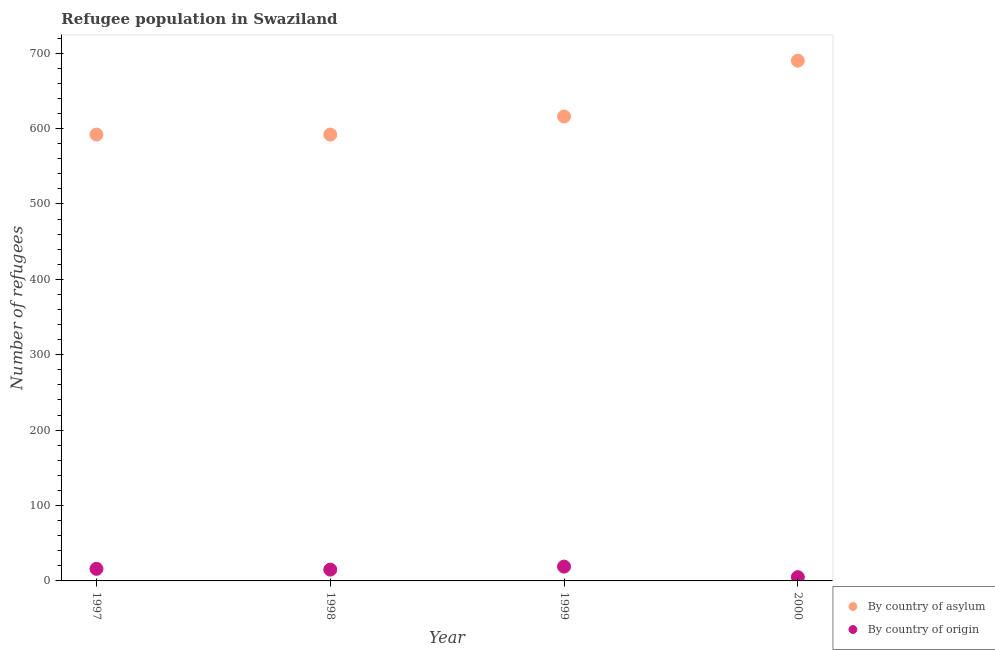How many different coloured dotlines are there?
Your answer should be compact. 2. Is the number of dotlines equal to the number of legend labels?
Offer a terse response. Yes. What is the number of refugees by country of asylum in 1997?
Offer a terse response. 592. Across all years, what is the maximum number of refugees by country of asylum?
Your response must be concise. 690. Across all years, what is the minimum number of refugees by country of origin?
Your answer should be very brief. 5. In which year was the number of refugees by country of origin maximum?
Give a very brief answer. 1999. In which year was the number of refugees by country of origin minimum?
Make the answer very short. 2000. What is the total number of refugees by country of asylum in the graph?
Ensure brevity in your answer.  2490. What is the difference between the number of refugees by country of asylum in 1997 and that in 2000?
Offer a very short reply. -98. What is the difference between the number of refugees by country of origin in 1997 and the number of refugees by country of asylum in 1999?
Give a very brief answer. -600. What is the average number of refugees by country of asylum per year?
Offer a very short reply. 622.5. In the year 1997, what is the difference between the number of refugees by country of asylum and number of refugees by country of origin?
Your answer should be compact. 576. In how many years, is the number of refugees by country of origin greater than 380?
Provide a short and direct response. 0. What is the ratio of the number of refugees by country of origin in 1998 to that in 2000?
Offer a terse response. 3. What is the difference between the highest and the lowest number of refugees by country of asylum?
Ensure brevity in your answer.  98. In how many years, is the number of refugees by country of origin greater than the average number of refugees by country of origin taken over all years?
Your answer should be compact. 3. How many dotlines are there?
Your response must be concise. 2. Does the graph contain any zero values?
Keep it short and to the point. No. Where does the legend appear in the graph?
Your answer should be compact. Bottom right. How many legend labels are there?
Provide a short and direct response. 2. How are the legend labels stacked?
Make the answer very short. Vertical. What is the title of the graph?
Keep it short and to the point. Refugee population in Swaziland. What is the label or title of the Y-axis?
Provide a succinct answer. Number of refugees. What is the Number of refugees in By country of asylum in 1997?
Give a very brief answer. 592. What is the Number of refugees in By country of origin in 1997?
Provide a short and direct response. 16. What is the Number of refugees in By country of asylum in 1998?
Make the answer very short. 592. What is the Number of refugees in By country of origin in 1998?
Provide a succinct answer. 15. What is the Number of refugees in By country of asylum in 1999?
Provide a succinct answer. 616. What is the Number of refugees in By country of origin in 1999?
Provide a succinct answer. 19. What is the Number of refugees in By country of asylum in 2000?
Give a very brief answer. 690. Across all years, what is the maximum Number of refugees of By country of asylum?
Provide a succinct answer. 690. Across all years, what is the minimum Number of refugees in By country of asylum?
Offer a very short reply. 592. What is the total Number of refugees of By country of asylum in the graph?
Make the answer very short. 2490. What is the total Number of refugees of By country of origin in the graph?
Give a very brief answer. 55. What is the difference between the Number of refugees of By country of asylum in 1997 and that in 1998?
Give a very brief answer. 0. What is the difference between the Number of refugees in By country of origin in 1997 and that in 1998?
Make the answer very short. 1. What is the difference between the Number of refugees of By country of asylum in 1997 and that in 1999?
Provide a short and direct response. -24. What is the difference between the Number of refugees in By country of origin in 1997 and that in 1999?
Your answer should be very brief. -3. What is the difference between the Number of refugees of By country of asylum in 1997 and that in 2000?
Your answer should be very brief. -98. What is the difference between the Number of refugees in By country of origin in 1997 and that in 2000?
Keep it short and to the point. 11. What is the difference between the Number of refugees of By country of asylum in 1998 and that in 1999?
Make the answer very short. -24. What is the difference between the Number of refugees of By country of origin in 1998 and that in 1999?
Your answer should be very brief. -4. What is the difference between the Number of refugees in By country of asylum in 1998 and that in 2000?
Your answer should be compact. -98. What is the difference between the Number of refugees in By country of origin in 1998 and that in 2000?
Make the answer very short. 10. What is the difference between the Number of refugees in By country of asylum in 1999 and that in 2000?
Your response must be concise. -74. What is the difference between the Number of refugees in By country of asylum in 1997 and the Number of refugees in By country of origin in 1998?
Ensure brevity in your answer.  577. What is the difference between the Number of refugees in By country of asylum in 1997 and the Number of refugees in By country of origin in 1999?
Provide a succinct answer. 573. What is the difference between the Number of refugees in By country of asylum in 1997 and the Number of refugees in By country of origin in 2000?
Offer a terse response. 587. What is the difference between the Number of refugees in By country of asylum in 1998 and the Number of refugees in By country of origin in 1999?
Ensure brevity in your answer.  573. What is the difference between the Number of refugees of By country of asylum in 1998 and the Number of refugees of By country of origin in 2000?
Keep it short and to the point. 587. What is the difference between the Number of refugees in By country of asylum in 1999 and the Number of refugees in By country of origin in 2000?
Ensure brevity in your answer.  611. What is the average Number of refugees of By country of asylum per year?
Give a very brief answer. 622.5. What is the average Number of refugees of By country of origin per year?
Your answer should be compact. 13.75. In the year 1997, what is the difference between the Number of refugees in By country of asylum and Number of refugees in By country of origin?
Your answer should be compact. 576. In the year 1998, what is the difference between the Number of refugees of By country of asylum and Number of refugees of By country of origin?
Make the answer very short. 577. In the year 1999, what is the difference between the Number of refugees of By country of asylum and Number of refugees of By country of origin?
Your answer should be very brief. 597. In the year 2000, what is the difference between the Number of refugees in By country of asylum and Number of refugees in By country of origin?
Give a very brief answer. 685. What is the ratio of the Number of refugees in By country of asylum in 1997 to that in 1998?
Provide a short and direct response. 1. What is the ratio of the Number of refugees in By country of origin in 1997 to that in 1998?
Make the answer very short. 1.07. What is the ratio of the Number of refugees of By country of origin in 1997 to that in 1999?
Offer a terse response. 0.84. What is the ratio of the Number of refugees of By country of asylum in 1997 to that in 2000?
Make the answer very short. 0.86. What is the ratio of the Number of refugees of By country of origin in 1998 to that in 1999?
Make the answer very short. 0.79. What is the ratio of the Number of refugees in By country of asylum in 1998 to that in 2000?
Ensure brevity in your answer.  0.86. What is the ratio of the Number of refugees of By country of asylum in 1999 to that in 2000?
Offer a very short reply. 0.89. What is the difference between the highest and the second highest Number of refugees in By country of asylum?
Your response must be concise. 74. What is the difference between the highest and the second highest Number of refugees in By country of origin?
Your response must be concise. 3. What is the difference between the highest and the lowest Number of refugees in By country of asylum?
Your answer should be very brief. 98. What is the difference between the highest and the lowest Number of refugees in By country of origin?
Offer a terse response. 14. 